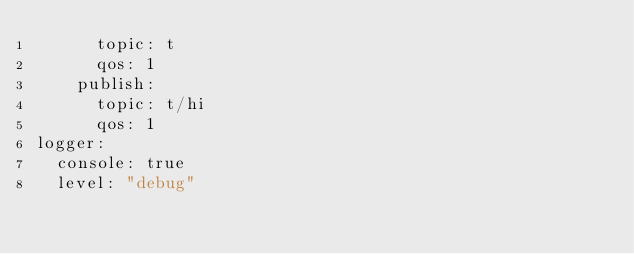<code> <loc_0><loc_0><loc_500><loc_500><_YAML_>      topic: t
      qos: 1
    publish:
      topic: t/hi
      qos: 1
logger:
  console: true
  level: "debug"
</code> 